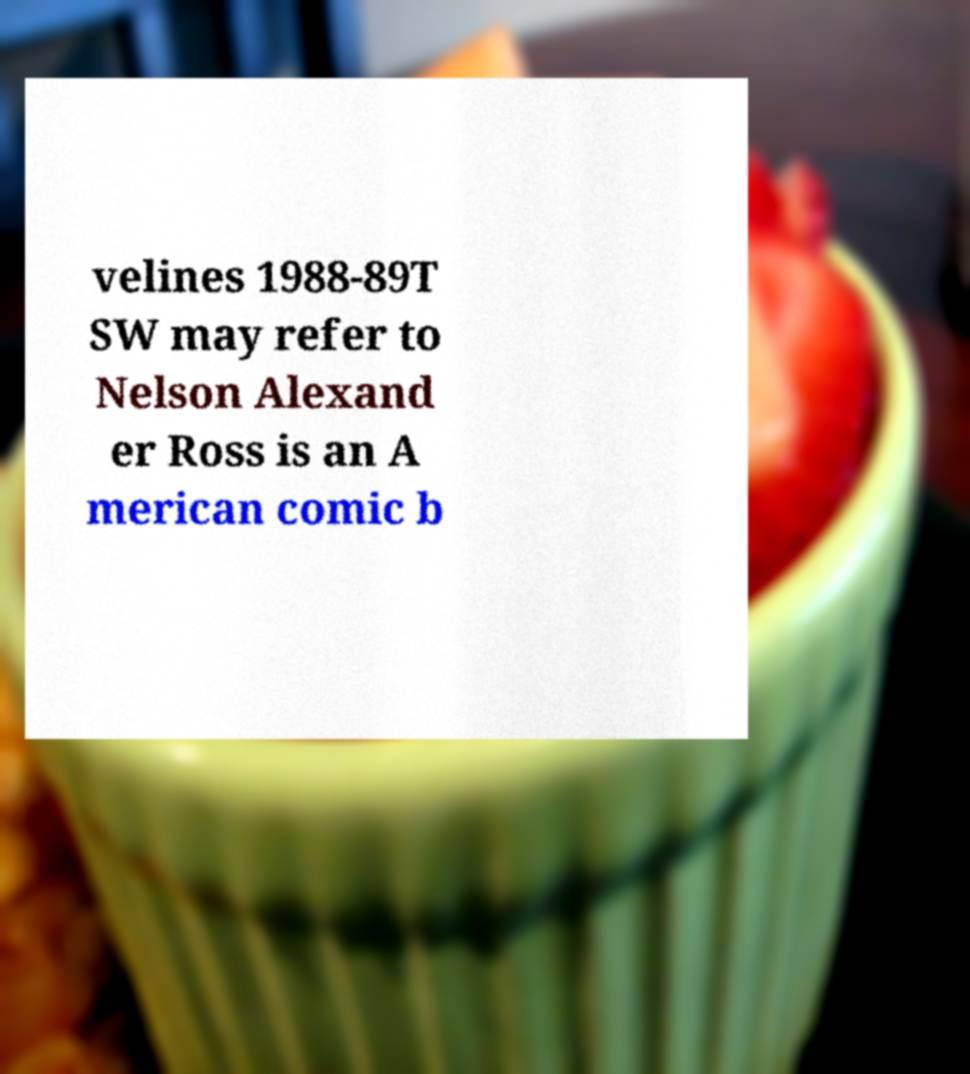What messages or text are displayed in this image? I need them in a readable, typed format. velines 1988-89T SW may refer to Nelson Alexand er Ross is an A merican comic b 